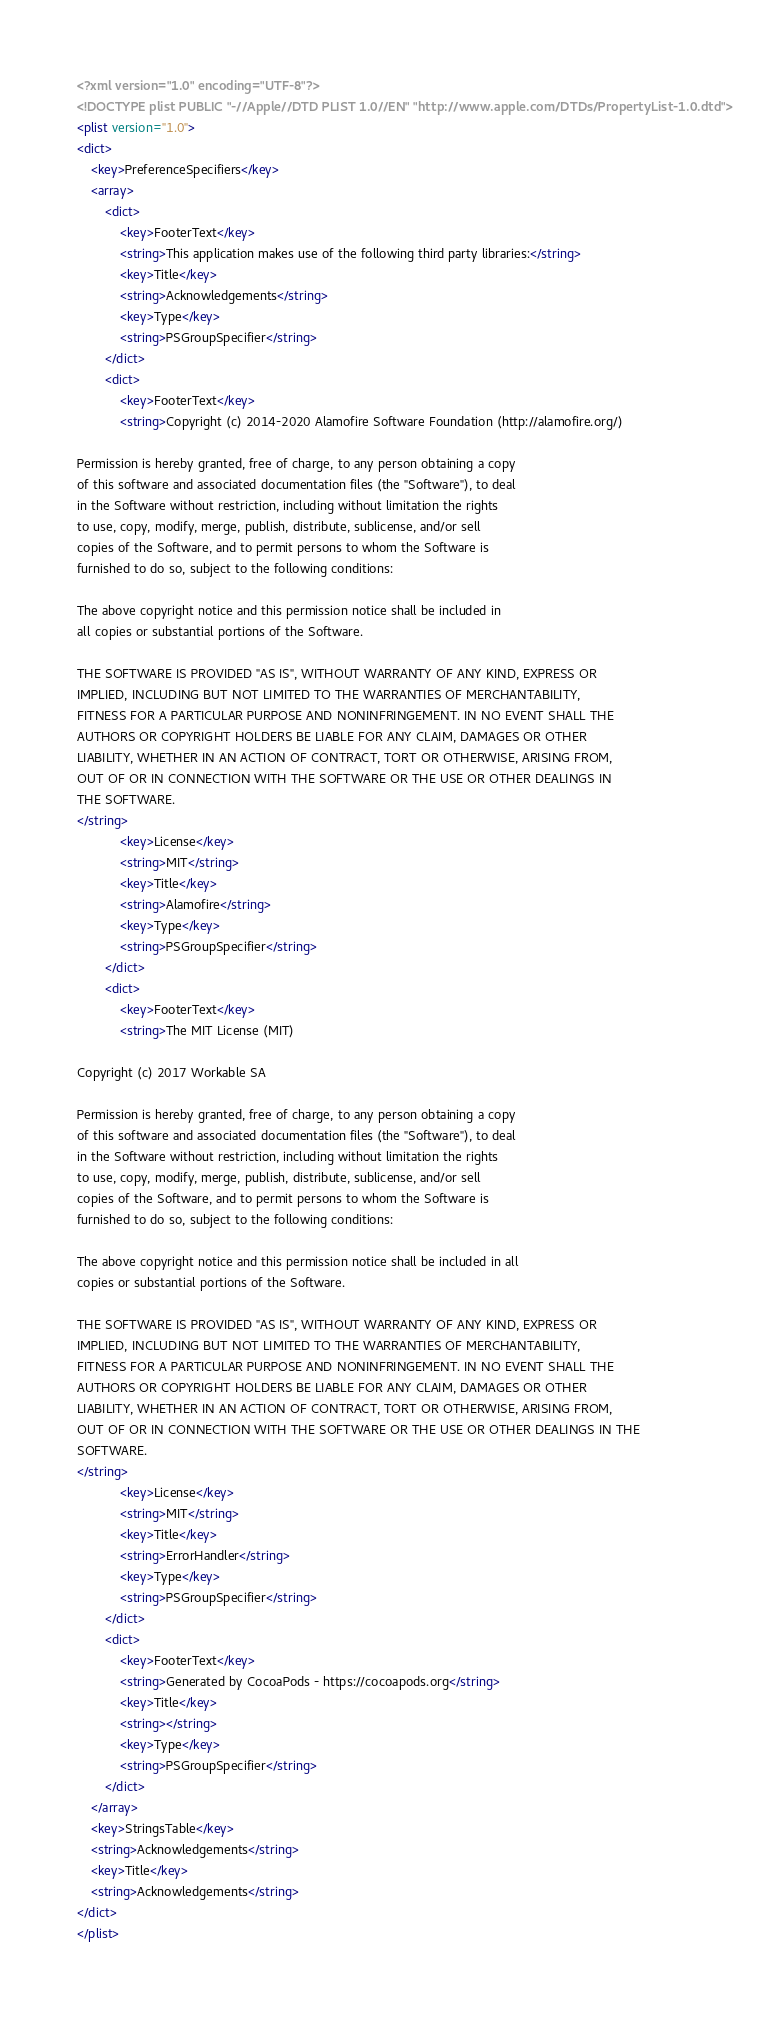<code> <loc_0><loc_0><loc_500><loc_500><_XML_><?xml version="1.0" encoding="UTF-8"?>
<!DOCTYPE plist PUBLIC "-//Apple//DTD PLIST 1.0//EN" "http://www.apple.com/DTDs/PropertyList-1.0.dtd">
<plist version="1.0">
<dict>
	<key>PreferenceSpecifiers</key>
	<array>
		<dict>
			<key>FooterText</key>
			<string>This application makes use of the following third party libraries:</string>
			<key>Title</key>
			<string>Acknowledgements</string>
			<key>Type</key>
			<string>PSGroupSpecifier</string>
		</dict>
		<dict>
			<key>FooterText</key>
			<string>Copyright (c) 2014-2020 Alamofire Software Foundation (http://alamofire.org/)

Permission is hereby granted, free of charge, to any person obtaining a copy
of this software and associated documentation files (the "Software"), to deal
in the Software without restriction, including without limitation the rights
to use, copy, modify, merge, publish, distribute, sublicense, and/or sell
copies of the Software, and to permit persons to whom the Software is
furnished to do so, subject to the following conditions:

The above copyright notice and this permission notice shall be included in
all copies or substantial portions of the Software.

THE SOFTWARE IS PROVIDED "AS IS", WITHOUT WARRANTY OF ANY KIND, EXPRESS OR
IMPLIED, INCLUDING BUT NOT LIMITED TO THE WARRANTIES OF MERCHANTABILITY,
FITNESS FOR A PARTICULAR PURPOSE AND NONINFRINGEMENT. IN NO EVENT SHALL THE
AUTHORS OR COPYRIGHT HOLDERS BE LIABLE FOR ANY CLAIM, DAMAGES OR OTHER
LIABILITY, WHETHER IN AN ACTION OF CONTRACT, TORT OR OTHERWISE, ARISING FROM,
OUT OF OR IN CONNECTION WITH THE SOFTWARE OR THE USE OR OTHER DEALINGS IN
THE SOFTWARE.
</string>
			<key>License</key>
			<string>MIT</string>
			<key>Title</key>
			<string>Alamofire</string>
			<key>Type</key>
			<string>PSGroupSpecifier</string>
		</dict>
		<dict>
			<key>FooterText</key>
			<string>The MIT License (MIT)

Copyright (c) 2017 Workable SA

Permission is hereby granted, free of charge, to any person obtaining a copy
of this software and associated documentation files (the "Software"), to deal
in the Software without restriction, including without limitation the rights
to use, copy, modify, merge, publish, distribute, sublicense, and/or sell
copies of the Software, and to permit persons to whom the Software is
furnished to do so, subject to the following conditions:

The above copyright notice and this permission notice shall be included in all
copies or substantial portions of the Software.

THE SOFTWARE IS PROVIDED "AS IS", WITHOUT WARRANTY OF ANY KIND, EXPRESS OR
IMPLIED, INCLUDING BUT NOT LIMITED TO THE WARRANTIES OF MERCHANTABILITY,
FITNESS FOR A PARTICULAR PURPOSE AND NONINFRINGEMENT. IN NO EVENT SHALL THE
AUTHORS OR COPYRIGHT HOLDERS BE LIABLE FOR ANY CLAIM, DAMAGES OR OTHER
LIABILITY, WHETHER IN AN ACTION OF CONTRACT, TORT OR OTHERWISE, ARISING FROM,
OUT OF OR IN CONNECTION WITH THE SOFTWARE OR THE USE OR OTHER DEALINGS IN THE
SOFTWARE.
</string>
			<key>License</key>
			<string>MIT</string>
			<key>Title</key>
			<string>ErrorHandler</string>
			<key>Type</key>
			<string>PSGroupSpecifier</string>
		</dict>
		<dict>
			<key>FooterText</key>
			<string>Generated by CocoaPods - https://cocoapods.org</string>
			<key>Title</key>
			<string></string>
			<key>Type</key>
			<string>PSGroupSpecifier</string>
		</dict>
	</array>
	<key>StringsTable</key>
	<string>Acknowledgements</string>
	<key>Title</key>
	<string>Acknowledgements</string>
</dict>
</plist>
</code> 